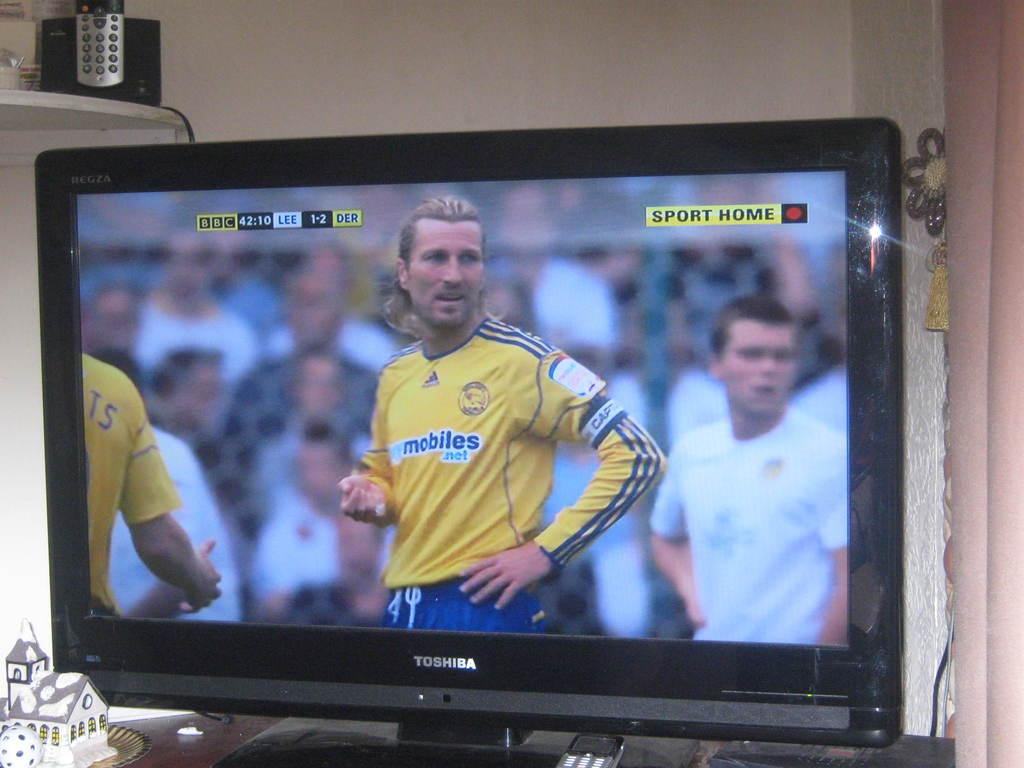<image>
Offer a succinct explanation of the picture presented. a man on the screen with a mobiles shirt on 